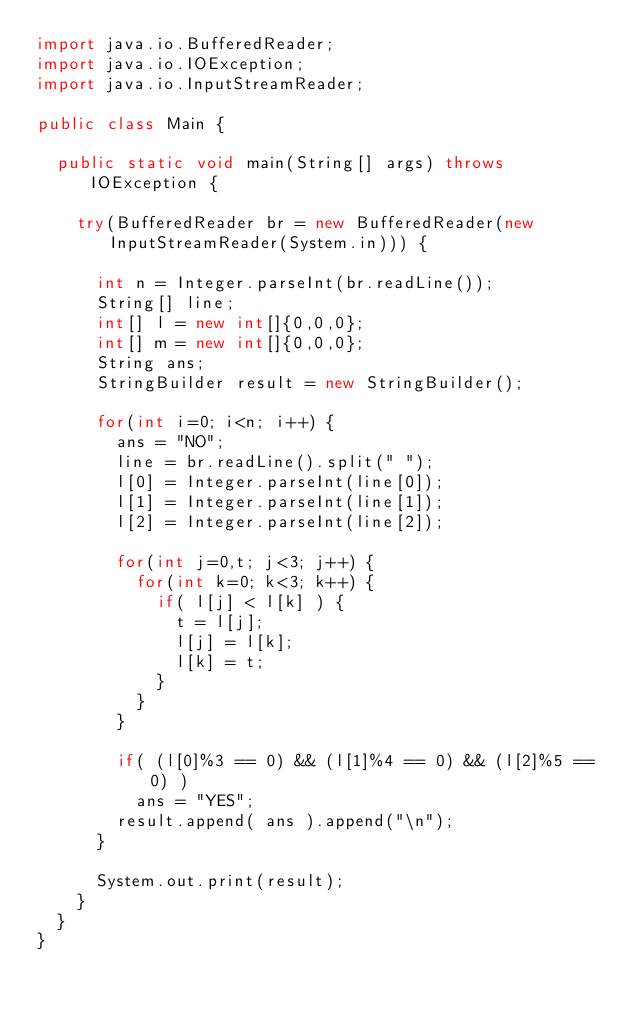Convert code to text. <code><loc_0><loc_0><loc_500><loc_500><_Java_>import java.io.BufferedReader;
import java.io.IOException;
import java.io.InputStreamReader;

public class Main {

  public static void main(String[] args) throws IOException {
    
    try(BufferedReader br = new BufferedReader(new InputStreamReader(System.in))) {

      int n = Integer.parseInt(br.readLine());
      String[] line;
      int[] l = new int[]{0,0,0};
      int[] m = new int[]{0,0,0};
      String ans;
      StringBuilder result = new StringBuilder();

      for(int i=0; i<n; i++) {
        ans = "NO";
        line = br.readLine().split(" ");
        l[0] = Integer.parseInt(line[0]);
        l[1] = Integer.parseInt(line[1]);
        l[2] = Integer.parseInt(line[2]);

        for(int j=0,t; j<3; j++) {
          for(int k=0; k<3; k++) {
            if( l[j] < l[k] ) {
              t = l[j];
              l[j] = l[k];
              l[k] = t;
            }
          }
        }

        if( (l[0]%3 == 0) && (l[1]%4 == 0) && (l[2]%5 == 0) )
          ans = "YES";
        result.append( ans ).append("\n");
      }

      System.out.print(result);
    }
  }
}
</code> 